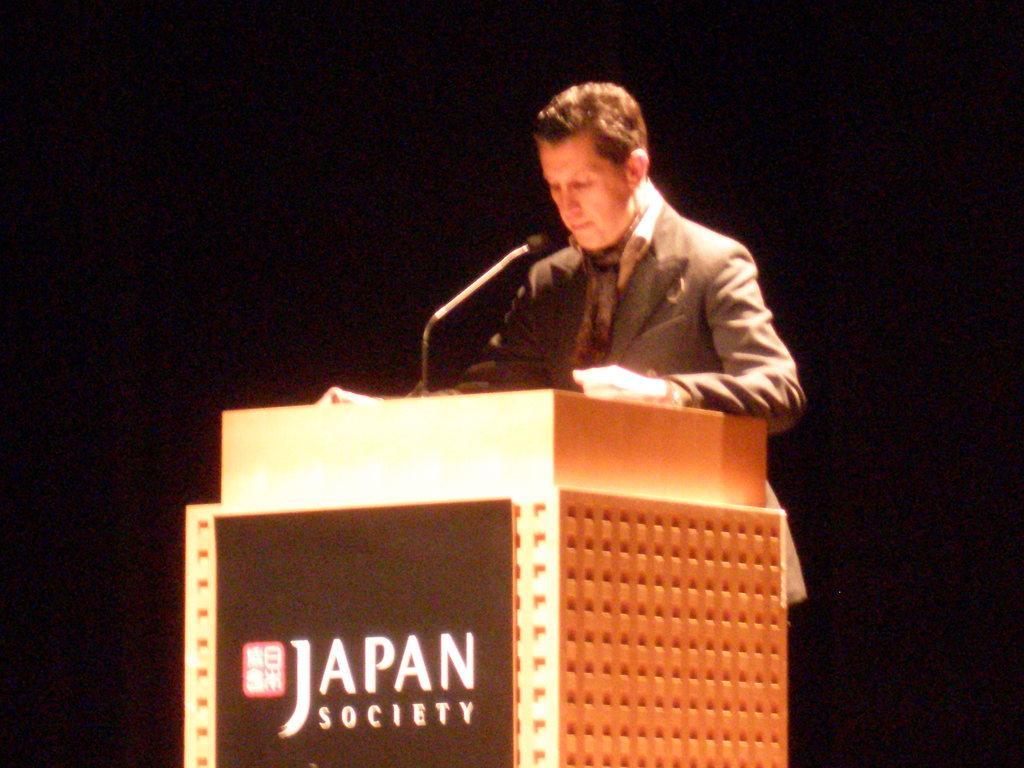Please provide a concise description of this image. In this picture we can see a person standing in front of a podium. There is some text visible on a podium. We can see a microphone on this podium. The background is dark. 